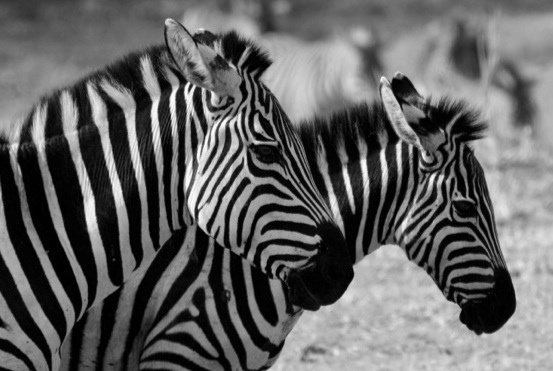Describe the objects in this image and their specific colors. I can see zebra in black, darkgray, gray, and lightgray tones and zebra in black, gray, darkgray, and lightgray tones in this image. 